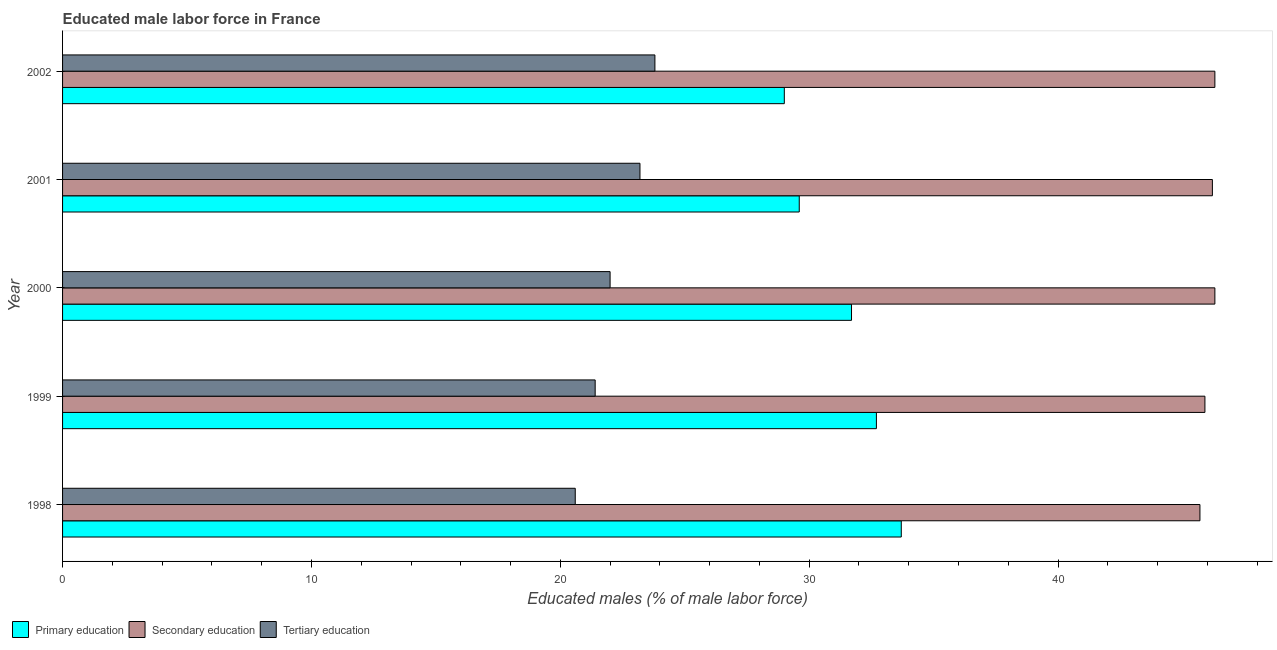How many different coloured bars are there?
Your answer should be very brief. 3. How many bars are there on the 5th tick from the top?
Offer a very short reply. 3. What is the percentage of male labor force who received tertiary education in 2002?
Your answer should be very brief. 23.8. Across all years, what is the maximum percentage of male labor force who received tertiary education?
Make the answer very short. 23.8. In which year was the percentage of male labor force who received primary education maximum?
Your answer should be compact. 1998. In which year was the percentage of male labor force who received secondary education minimum?
Ensure brevity in your answer.  1998. What is the total percentage of male labor force who received tertiary education in the graph?
Keep it short and to the point. 111. What is the difference between the percentage of male labor force who received primary education in 2002 and the percentage of male labor force who received secondary education in 2000?
Keep it short and to the point. -17.3. What is the average percentage of male labor force who received secondary education per year?
Offer a terse response. 46.08. In the year 1998, what is the difference between the percentage of male labor force who received secondary education and percentage of male labor force who received tertiary education?
Your answer should be compact. 25.1. Is the percentage of male labor force who received secondary education in 1999 less than that in 2002?
Your response must be concise. Yes. What is the difference between the highest and the lowest percentage of male labor force who received primary education?
Provide a short and direct response. 4.7. In how many years, is the percentage of male labor force who received secondary education greater than the average percentage of male labor force who received secondary education taken over all years?
Give a very brief answer. 3. What does the 2nd bar from the bottom in 2001 represents?
Offer a terse response. Secondary education. Is it the case that in every year, the sum of the percentage of male labor force who received primary education and percentage of male labor force who received secondary education is greater than the percentage of male labor force who received tertiary education?
Make the answer very short. Yes. Are the values on the major ticks of X-axis written in scientific E-notation?
Provide a short and direct response. No. How many legend labels are there?
Your answer should be very brief. 3. How are the legend labels stacked?
Give a very brief answer. Horizontal. What is the title of the graph?
Offer a very short reply. Educated male labor force in France. What is the label or title of the X-axis?
Keep it short and to the point. Educated males (% of male labor force). What is the label or title of the Y-axis?
Offer a very short reply. Year. What is the Educated males (% of male labor force) of Primary education in 1998?
Provide a succinct answer. 33.7. What is the Educated males (% of male labor force) in Secondary education in 1998?
Make the answer very short. 45.7. What is the Educated males (% of male labor force) in Tertiary education in 1998?
Make the answer very short. 20.6. What is the Educated males (% of male labor force) in Primary education in 1999?
Provide a succinct answer. 32.7. What is the Educated males (% of male labor force) of Secondary education in 1999?
Your answer should be compact. 45.9. What is the Educated males (% of male labor force) in Tertiary education in 1999?
Make the answer very short. 21.4. What is the Educated males (% of male labor force) in Primary education in 2000?
Offer a very short reply. 31.7. What is the Educated males (% of male labor force) in Secondary education in 2000?
Provide a short and direct response. 46.3. What is the Educated males (% of male labor force) in Primary education in 2001?
Offer a terse response. 29.6. What is the Educated males (% of male labor force) in Secondary education in 2001?
Give a very brief answer. 46.2. What is the Educated males (% of male labor force) in Tertiary education in 2001?
Ensure brevity in your answer.  23.2. What is the Educated males (% of male labor force) of Secondary education in 2002?
Make the answer very short. 46.3. What is the Educated males (% of male labor force) in Tertiary education in 2002?
Your response must be concise. 23.8. Across all years, what is the maximum Educated males (% of male labor force) in Primary education?
Ensure brevity in your answer.  33.7. Across all years, what is the maximum Educated males (% of male labor force) of Secondary education?
Make the answer very short. 46.3. Across all years, what is the maximum Educated males (% of male labor force) in Tertiary education?
Keep it short and to the point. 23.8. Across all years, what is the minimum Educated males (% of male labor force) in Primary education?
Offer a terse response. 29. Across all years, what is the minimum Educated males (% of male labor force) in Secondary education?
Give a very brief answer. 45.7. Across all years, what is the minimum Educated males (% of male labor force) in Tertiary education?
Your response must be concise. 20.6. What is the total Educated males (% of male labor force) of Primary education in the graph?
Your answer should be compact. 156.7. What is the total Educated males (% of male labor force) in Secondary education in the graph?
Your answer should be compact. 230.4. What is the total Educated males (% of male labor force) of Tertiary education in the graph?
Provide a short and direct response. 111. What is the difference between the Educated males (% of male labor force) of Secondary education in 1998 and that in 1999?
Your answer should be very brief. -0.2. What is the difference between the Educated males (% of male labor force) in Tertiary education in 1998 and that in 1999?
Make the answer very short. -0.8. What is the difference between the Educated males (% of male labor force) in Primary education in 1998 and that in 2001?
Ensure brevity in your answer.  4.1. What is the difference between the Educated males (% of male labor force) in Primary education in 1998 and that in 2002?
Give a very brief answer. 4.7. What is the difference between the Educated males (% of male labor force) of Tertiary education in 1998 and that in 2002?
Offer a very short reply. -3.2. What is the difference between the Educated males (% of male labor force) in Primary education in 1999 and that in 2000?
Give a very brief answer. 1. What is the difference between the Educated males (% of male labor force) of Tertiary education in 1999 and that in 2001?
Keep it short and to the point. -1.8. What is the difference between the Educated males (% of male labor force) of Primary education in 1999 and that in 2002?
Make the answer very short. 3.7. What is the difference between the Educated males (% of male labor force) in Secondary education in 1999 and that in 2002?
Your response must be concise. -0.4. What is the difference between the Educated males (% of male labor force) of Tertiary education in 1999 and that in 2002?
Your answer should be very brief. -2.4. What is the difference between the Educated males (% of male labor force) in Primary education in 2000 and that in 2001?
Your answer should be very brief. 2.1. What is the difference between the Educated males (% of male labor force) in Tertiary education in 2000 and that in 2001?
Your response must be concise. -1.2. What is the difference between the Educated males (% of male labor force) of Primary education in 2000 and that in 2002?
Offer a terse response. 2.7. What is the difference between the Educated males (% of male labor force) of Tertiary education in 2000 and that in 2002?
Offer a terse response. -1.8. What is the difference between the Educated males (% of male labor force) in Secondary education in 2001 and that in 2002?
Keep it short and to the point. -0.1. What is the difference between the Educated males (% of male labor force) in Tertiary education in 2001 and that in 2002?
Make the answer very short. -0.6. What is the difference between the Educated males (% of male labor force) of Primary education in 1998 and the Educated males (% of male labor force) of Tertiary education in 1999?
Your answer should be very brief. 12.3. What is the difference between the Educated males (% of male labor force) of Secondary education in 1998 and the Educated males (% of male labor force) of Tertiary education in 1999?
Keep it short and to the point. 24.3. What is the difference between the Educated males (% of male labor force) in Primary education in 1998 and the Educated males (% of male labor force) in Secondary education in 2000?
Provide a succinct answer. -12.6. What is the difference between the Educated males (% of male labor force) in Primary education in 1998 and the Educated males (% of male labor force) in Tertiary education in 2000?
Make the answer very short. 11.7. What is the difference between the Educated males (% of male labor force) of Secondary education in 1998 and the Educated males (% of male labor force) of Tertiary education in 2000?
Give a very brief answer. 23.7. What is the difference between the Educated males (% of male labor force) in Primary education in 1998 and the Educated males (% of male labor force) in Secondary education in 2001?
Offer a very short reply. -12.5. What is the difference between the Educated males (% of male labor force) of Secondary education in 1998 and the Educated males (% of male labor force) of Tertiary education in 2001?
Provide a short and direct response. 22.5. What is the difference between the Educated males (% of male labor force) in Secondary education in 1998 and the Educated males (% of male labor force) in Tertiary education in 2002?
Your answer should be very brief. 21.9. What is the difference between the Educated males (% of male labor force) in Primary education in 1999 and the Educated males (% of male labor force) in Secondary education in 2000?
Give a very brief answer. -13.6. What is the difference between the Educated males (% of male labor force) of Secondary education in 1999 and the Educated males (% of male labor force) of Tertiary education in 2000?
Make the answer very short. 23.9. What is the difference between the Educated males (% of male labor force) of Primary education in 1999 and the Educated males (% of male labor force) of Tertiary education in 2001?
Offer a very short reply. 9.5. What is the difference between the Educated males (% of male labor force) of Secondary education in 1999 and the Educated males (% of male labor force) of Tertiary education in 2001?
Your answer should be compact. 22.7. What is the difference between the Educated males (% of male labor force) in Secondary education in 1999 and the Educated males (% of male labor force) in Tertiary education in 2002?
Provide a succinct answer. 22.1. What is the difference between the Educated males (% of male labor force) in Primary education in 2000 and the Educated males (% of male labor force) in Tertiary education in 2001?
Offer a terse response. 8.5. What is the difference between the Educated males (% of male labor force) of Secondary education in 2000 and the Educated males (% of male labor force) of Tertiary education in 2001?
Make the answer very short. 23.1. What is the difference between the Educated males (% of male labor force) in Primary education in 2000 and the Educated males (% of male labor force) in Secondary education in 2002?
Your response must be concise. -14.6. What is the difference between the Educated males (% of male labor force) of Primary education in 2001 and the Educated males (% of male labor force) of Secondary education in 2002?
Provide a short and direct response. -16.7. What is the difference between the Educated males (% of male labor force) of Primary education in 2001 and the Educated males (% of male labor force) of Tertiary education in 2002?
Offer a very short reply. 5.8. What is the difference between the Educated males (% of male labor force) of Secondary education in 2001 and the Educated males (% of male labor force) of Tertiary education in 2002?
Give a very brief answer. 22.4. What is the average Educated males (% of male labor force) of Primary education per year?
Keep it short and to the point. 31.34. What is the average Educated males (% of male labor force) of Secondary education per year?
Provide a short and direct response. 46.08. In the year 1998, what is the difference between the Educated males (% of male labor force) in Primary education and Educated males (% of male labor force) in Tertiary education?
Give a very brief answer. 13.1. In the year 1998, what is the difference between the Educated males (% of male labor force) of Secondary education and Educated males (% of male labor force) of Tertiary education?
Offer a very short reply. 25.1. In the year 1999, what is the difference between the Educated males (% of male labor force) in Primary education and Educated males (% of male labor force) in Tertiary education?
Offer a very short reply. 11.3. In the year 1999, what is the difference between the Educated males (% of male labor force) in Secondary education and Educated males (% of male labor force) in Tertiary education?
Your answer should be very brief. 24.5. In the year 2000, what is the difference between the Educated males (% of male labor force) in Primary education and Educated males (% of male labor force) in Secondary education?
Give a very brief answer. -14.6. In the year 2000, what is the difference between the Educated males (% of male labor force) of Primary education and Educated males (% of male labor force) of Tertiary education?
Offer a very short reply. 9.7. In the year 2000, what is the difference between the Educated males (% of male labor force) in Secondary education and Educated males (% of male labor force) in Tertiary education?
Your answer should be very brief. 24.3. In the year 2001, what is the difference between the Educated males (% of male labor force) of Primary education and Educated males (% of male labor force) of Secondary education?
Ensure brevity in your answer.  -16.6. In the year 2001, what is the difference between the Educated males (% of male labor force) of Primary education and Educated males (% of male labor force) of Tertiary education?
Provide a short and direct response. 6.4. In the year 2002, what is the difference between the Educated males (% of male labor force) of Primary education and Educated males (% of male labor force) of Secondary education?
Provide a succinct answer. -17.3. In the year 2002, what is the difference between the Educated males (% of male labor force) of Primary education and Educated males (% of male labor force) of Tertiary education?
Make the answer very short. 5.2. In the year 2002, what is the difference between the Educated males (% of male labor force) in Secondary education and Educated males (% of male labor force) in Tertiary education?
Offer a very short reply. 22.5. What is the ratio of the Educated males (% of male labor force) in Primary education in 1998 to that in 1999?
Your answer should be very brief. 1.03. What is the ratio of the Educated males (% of male labor force) in Secondary education in 1998 to that in 1999?
Provide a succinct answer. 1. What is the ratio of the Educated males (% of male labor force) of Tertiary education in 1998 to that in 1999?
Make the answer very short. 0.96. What is the ratio of the Educated males (% of male labor force) in Primary education in 1998 to that in 2000?
Your answer should be very brief. 1.06. What is the ratio of the Educated males (% of male labor force) of Secondary education in 1998 to that in 2000?
Your response must be concise. 0.99. What is the ratio of the Educated males (% of male labor force) of Tertiary education in 1998 to that in 2000?
Ensure brevity in your answer.  0.94. What is the ratio of the Educated males (% of male labor force) of Primary education in 1998 to that in 2001?
Provide a succinct answer. 1.14. What is the ratio of the Educated males (% of male labor force) of Secondary education in 1998 to that in 2001?
Your response must be concise. 0.99. What is the ratio of the Educated males (% of male labor force) in Tertiary education in 1998 to that in 2001?
Your response must be concise. 0.89. What is the ratio of the Educated males (% of male labor force) in Primary education in 1998 to that in 2002?
Your response must be concise. 1.16. What is the ratio of the Educated males (% of male labor force) of Tertiary education in 1998 to that in 2002?
Provide a succinct answer. 0.87. What is the ratio of the Educated males (% of male labor force) of Primary education in 1999 to that in 2000?
Give a very brief answer. 1.03. What is the ratio of the Educated males (% of male labor force) in Secondary education in 1999 to that in 2000?
Your response must be concise. 0.99. What is the ratio of the Educated males (% of male labor force) of Tertiary education in 1999 to that in 2000?
Your response must be concise. 0.97. What is the ratio of the Educated males (% of male labor force) in Primary education in 1999 to that in 2001?
Ensure brevity in your answer.  1.1. What is the ratio of the Educated males (% of male labor force) in Secondary education in 1999 to that in 2001?
Offer a very short reply. 0.99. What is the ratio of the Educated males (% of male labor force) of Tertiary education in 1999 to that in 2001?
Give a very brief answer. 0.92. What is the ratio of the Educated males (% of male labor force) in Primary education in 1999 to that in 2002?
Give a very brief answer. 1.13. What is the ratio of the Educated males (% of male labor force) of Secondary education in 1999 to that in 2002?
Keep it short and to the point. 0.99. What is the ratio of the Educated males (% of male labor force) of Tertiary education in 1999 to that in 2002?
Make the answer very short. 0.9. What is the ratio of the Educated males (% of male labor force) of Primary education in 2000 to that in 2001?
Give a very brief answer. 1.07. What is the ratio of the Educated males (% of male labor force) in Secondary education in 2000 to that in 2001?
Provide a succinct answer. 1. What is the ratio of the Educated males (% of male labor force) in Tertiary education in 2000 to that in 2001?
Provide a short and direct response. 0.95. What is the ratio of the Educated males (% of male labor force) in Primary education in 2000 to that in 2002?
Provide a succinct answer. 1.09. What is the ratio of the Educated males (% of male labor force) of Tertiary education in 2000 to that in 2002?
Ensure brevity in your answer.  0.92. What is the ratio of the Educated males (% of male labor force) in Primary education in 2001 to that in 2002?
Make the answer very short. 1.02. What is the ratio of the Educated males (% of male labor force) of Secondary education in 2001 to that in 2002?
Keep it short and to the point. 1. What is the ratio of the Educated males (% of male labor force) in Tertiary education in 2001 to that in 2002?
Offer a very short reply. 0.97. What is the difference between the highest and the second highest Educated males (% of male labor force) in Secondary education?
Offer a very short reply. 0. What is the difference between the highest and the lowest Educated males (% of male labor force) in Secondary education?
Provide a short and direct response. 0.6. What is the difference between the highest and the lowest Educated males (% of male labor force) of Tertiary education?
Your answer should be very brief. 3.2. 